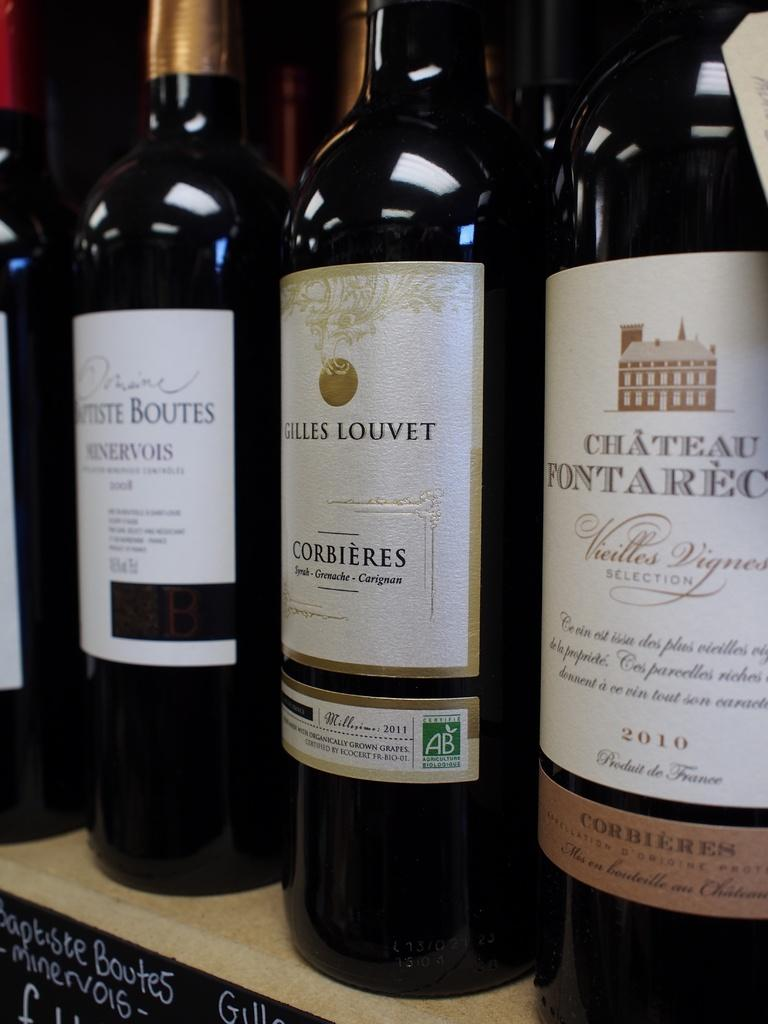Provide a one-sentence caption for the provided image. Bottles of wine, including Gilles Louvet, are lined up on a counter. 